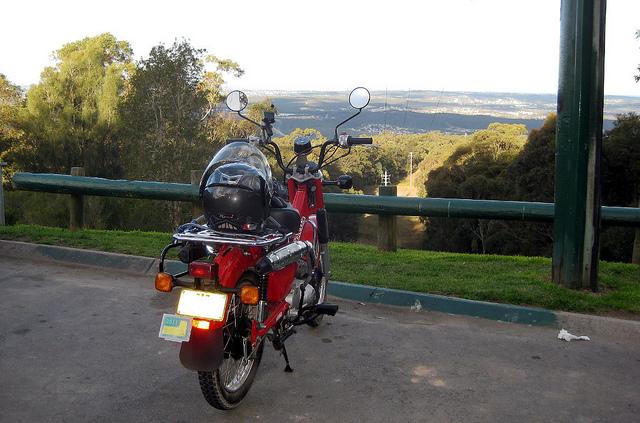What is on the ground next to the bike?
Short answer required. Trash. Is the bike parked?
Write a very short answer. Yes. Is the motorcycle moving?
Be succinct. No. How many tires are on the bike?
Give a very brief answer. 2. 